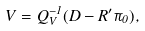Convert formula to latex. <formula><loc_0><loc_0><loc_500><loc_500>V = Q _ { V } ^ { - 1 } ( D - R ^ { \prime } \pi _ { 0 } ) ,</formula> 